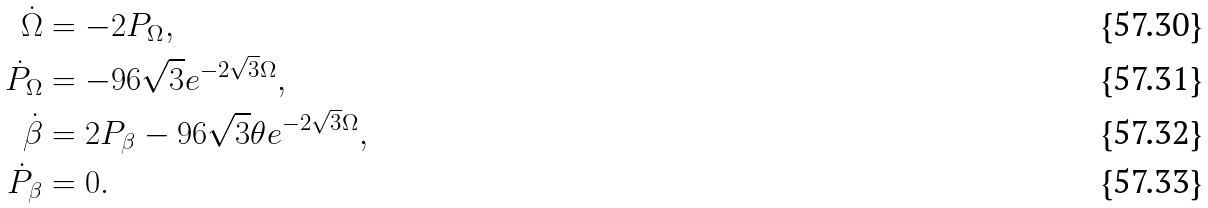Convert formula to latex. <formula><loc_0><loc_0><loc_500><loc_500>\dot { \Omega } & = - 2 P _ { \Omega } , \\ \dot { P } _ { \Omega } & = - 9 6 \sqrt { 3 } e ^ { - 2 \sqrt { 3 } \Omega } , \\ \dot { \beta } & = 2 P _ { \beta } - 9 6 \sqrt { 3 } \theta e ^ { - 2 \sqrt { 3 } \Omega } , \\ \dot { P } _ { \beta } & = 0 .</formula> 